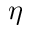<formula> <loc_0><loc_0><loc_500><loc_500>\eta</formula> 